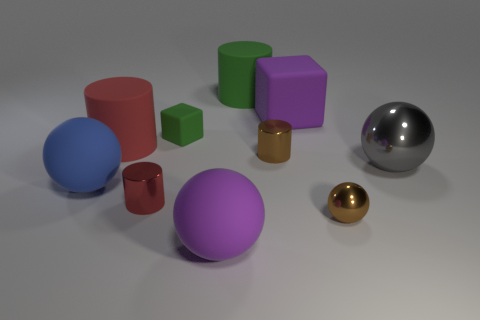How many objects are brown things that are on the right side of the large purple cube or big red things?
Provide a succinct answer. 2. There is a green rubber object that is behind the small thing behind the large matte cylinder that is to the left of the small green object; what is its shape?
Provide a succinct answer. Cylinder. What shape is the large red thing that is the same material as the blue object?
Provide a succinct answer. Cylinder. How big is the gray metal thing?
Make the answer very short. Large. Is the purple sphere the same size as the brown ball?
Give a very brief answer. No. How many objects are big purple rubber objects behind the large red cylinder or rubber objects left of the big green cylinder?
Provide a succinct answer. 5. How many small matte blocks are behind the large purple thing behind the big rubber sphere in front of the tiny sphere?
Make the answer very short. 0. There is a ball in front of the small brown metallic ball; how big is it?
Provide a succinct answer. Large. What number of brown metallic objects are the same size as the brown shiny sphere?
Make the answer very short. 1. There is a red metallic thing; is it the same size as the matte sphere in front of the blue rubber object?
Your answer should be compact. No. 